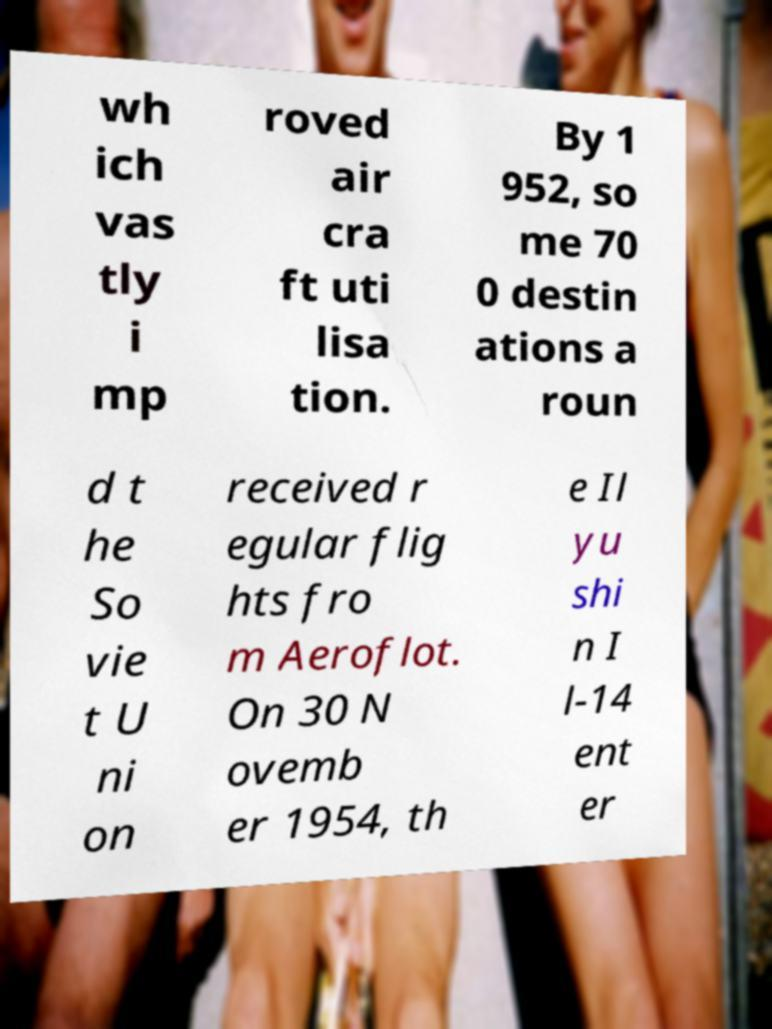There's text embedded in this image that I need extracted. Can you transcribe it verbatim? wh ich vas tly i mp roved air cra ft uti lisa tion. By 1 952, so me 70 0 destin ations a roun d t he So vie t U ni on received r egular flig hts fro m Aeroflot. On 30 N ovemb er 1954, th e Il yu shi n I l-14 ent er 